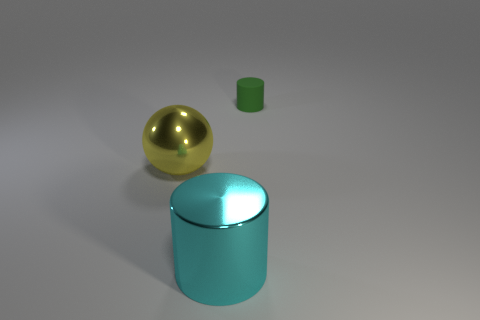Is the matte thing the same shape as the yellow metal thing?
Your response must be concise. No. What material is the object that is both in front of the rubber cylinder and on the right side of the yellow object?
Make the answer very short. Metal. The metal cylinder is what size?
Your response must be concise. Large. What color is the small matte thing that is the same shape as the big cyan thing?
Provide a short and direct response. Green. Is there anything else that is the same color as the shiny cylinder?
Make the answer very short. No. There is a cylinder that is in front of the tiny green thing; is it the same size as the shiny object to the left of the large cyan shiny cylinder?
Give a very brief answer. Yes. Are there the same number of balls behind the cyan metallic cylinder and cyan shiny cylinders in front of the tiny green cylinder?
Provide a succinct answer. Yes. There is a yellow ball; is its size the same as the cylinder in front of the small green matte object?
Offer a terse response. Yes. There is a cylinder on the left side of the small object; are there any objects that are left of it?
Provide a short and direct response. Yes. Is there another object that has the same shape as the cyan metallic thing?
Make the answer very short. Yes. 